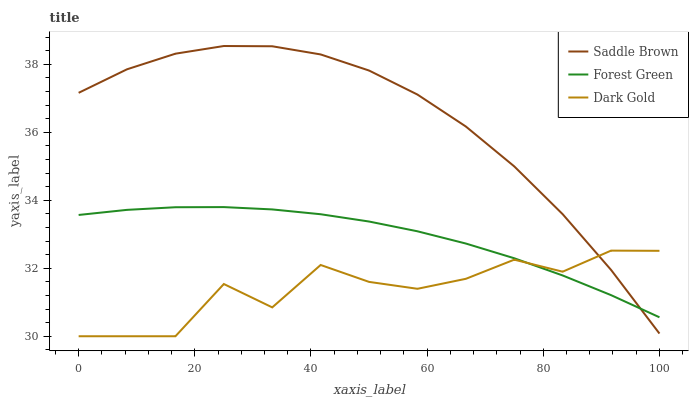Does Dark Gold have the minimum area under the curve?
Answer yes or no. Yes. Does Saddle Brown have the maximum area under the curve?
Answer yes or no. Yes. Does Saddle Brown have the minimum area under the curve?
Answer yes or no. No. Does Dark Gold have the maximum area under the curve?
Answer yes or no. No. Is Forest Green the smoothest?
Answer yes or no. Yes. Is Dark Gold the roughest?
Answer yes or no. Yes. Is Saddle Brown the smoothest?
Answer yes or no. No. Is Saddle Brown the roughest?
Answer yes or no. No. Does Dark Gold have the lowest value?
Answer yes or no. Yes. Does Saddle Brown have the lowest value?
Answer yes or no. No. Does Saddle Brown have the highest value?
Answer yes or no. Yes. Does Dark Gold have the highest value?
Answer yes or no. No. Does Forest Green intersect Saddle Brown?
Answer yes or no. Yes. Is Forest Green less than Saddle Brown?
Answer yes or no. No. Is Forest Green greater than Saddle Brown?
Answer yes or no. No. 